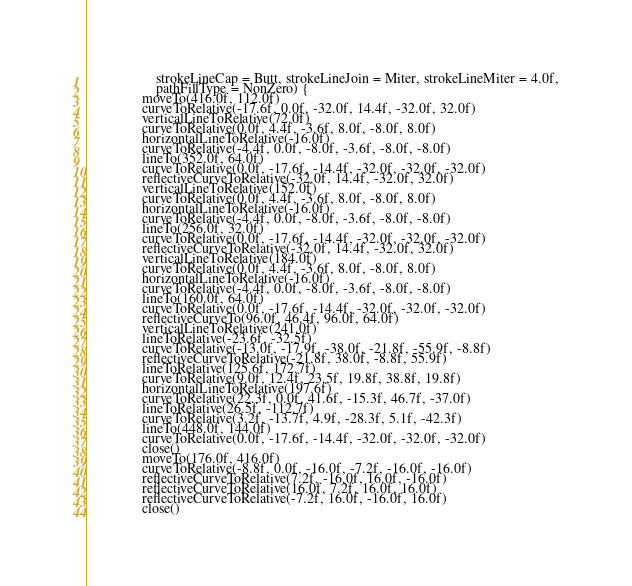<code> <loc_0><loc_0><loc_500><loc_500><_Kotlin_>                    strokeLineCap = Butt, strokeLineJoin = Miter, strokeLineMiter = 4.0f,
                    pathFillType = NonZero) {
                moveTo(416.0f, 112.0f)
                curveToRelative(-17.6f, 0.0f, -32.0f, 14.4f, -32.0f, 32.0f)
                verticalLineToRelative(72.0f)
                curveToRelative(0.0f, 4.4f, -3.6f, 8.0f, -8.0f, 8.0f)
                horizontalLineToRelative(-16.0f)
                curveToRelative(-4.4f, 0.0f, -8.0f, -3.6f, -8.0f, -8.0f)
                lineTo(352.0f, 64.0f)
                curveToRelative(0.0f, -17.6f, -14.4f, -32.0f, -32.0f, -32.0f)
                reflectiveCurveToRelative(-32.0f, 14.4f, -32.0f, 32.0f)
                verticalLineToRelative(152.0f)
                curveToRelative(0.0f, 4.4f, -3.6f, 8.0f, -8.0f, 8.0f)
                horizontalLineToRelative(-16.0f)
                curveToRelative(-4.4f, 0.0f, -8.0f, -3.6f, -8.0f, -8.0f)
                lineTo(256.0f, 32.0f)
                curveToRelative(0.0f, -17.6f, -14.4f, -32.0f, -32.0f, -32.0f)
                reflectiveCurveToRelative(-32.0f, 14.4f, -32.0f, 32.0f)
                verticalLineToRelative(184.0f)
                curveToRelative(0.0f, 4.4f, -3.6f, 8.0f, -8.0f, 8.0f)
                horizontalLineToRelative(-16.0f)
                curveToRelative(-4.4f, 0.0f, -8.0f, -3.6f, -8.0f, -8.0f)
                lineTo(160.0f, 64.0f)
                curveToRelative(0.0f, -17.6f, -14.4f, -32.0f, -32.0f, -32.0f)
                reflectiveCurveTo(96.0f, 46.4f, 96.0f, 64.0f)
                verticalLineToRelative(241.0f)
                lineToRelative(-23.6f, -32.5f)
                curveToRelative(-13.0f, -17.9f, -38.0f, -21.8f, -55.9f, -8.8f)
                reflectiveCurveToRelative(-21.8f, 38.0f, -8.8f, 55.9f)
                lineToRelative(125.6f, 172.7f)
                curveToRelative(9.0f, 12.4f, 23.5f, 19.8f, 38.8f, 19.8f)
                horizontalLineToRelative(197.6f)
                curveToRelative(22.3f, 0.0f, 41.6f, -15.3f, 46.7f, -37.0f)
                lineToRelative(26.5f, -112.7f)
                curveToRelative(3.2f, -13.7f, 4.9f, -28.3f, 5.1f, -42.3f)
                lineTo(448.0f, 144.0f)
                curveToRelative(0.0f, -17.6f, -14.4f, -32.0f, -32.0f, -32.0f)
                close()
                moveTo(176.0f, 416.0f)
                curveToRelative(-8.8f, 0.0f, -16.0f, -7.2f, -16.0f, -16.0f)
                reflectiveCurveToRelative(7.2f, -16.0f, 16.0f, -16.0f)
                reflectiveCurveToRelative(16.0f, 7.2f, 16.0f, 16.0f)
                reflectiveCurveToRelative(-7.2f, 16.0f, -16.0f, 16.0f)
                close()</code> 